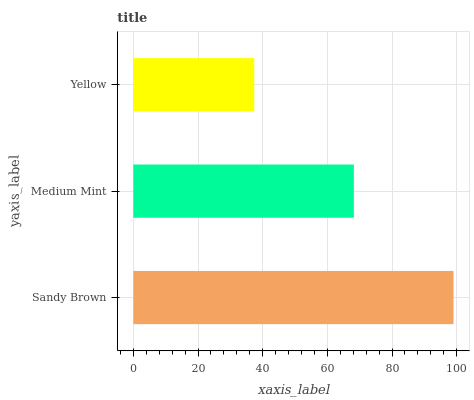Is Yellow the minimum?
Answer yes or no. Yes. Is Sandy Brown the maximum?
Answer yes or no. Yes. Is Medium Mint the minimum?
Answer yes or no. No. Is Medium Mint the maximum?
Answer yes or no. No. Is Sandy Brown greater than Medium Mint?
Answer yes or no. Yes. Is Medium Mint less than Sandy Brown?
Answer yes or no. Yes. Is Medium Mint greater than Sandy Brown?
Answer yes or no. No. Is Sandy Brown less than Medium Mint?
Answer yes or no. No. Is Medium Mint the high median?
Answer yes or no. Yes. Is Medium Mint the low median?
Answer yes or no. Yes. Is Sandy Brown the high median?
Answer yes or no. No. Is Sandy Brown the low median?
Answer yes or no. No. 